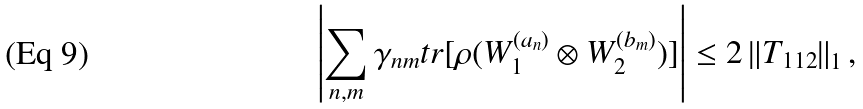<formula> <loc_0><loc_0><loc_500><loc_500>\left | \sum _ { n , m } \gamma _ { n m } t r [ \rho ( W _ { 1 } ^ { ( a _ { n } ) } \otimes W _ { 2 } ^ { ( b _ { m } ) } ) ] \right | \leq 2 \left \| T _ { 1 1 2 } \right \| _ { 1 } ,</formula> 